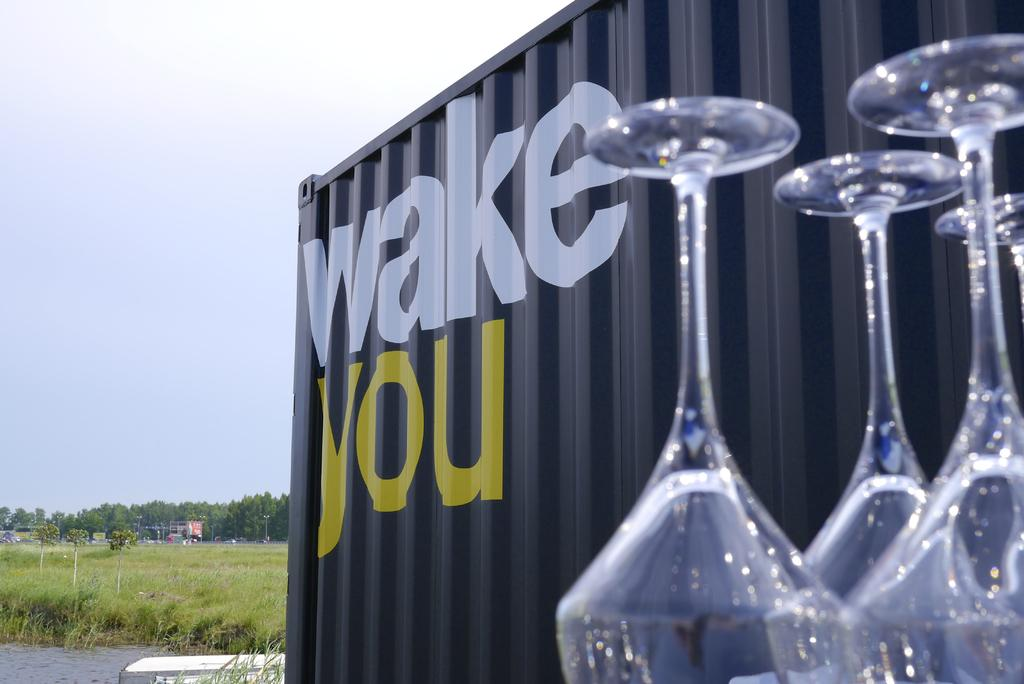What objects can be seen in the image? There are glasses and a metal object in the image. Where is the metal object located? The metal object is on the right side of the image. What can be seen in the background of the image? The sky is visible in the background of the image. What type of landscape is present in the image? There is a field in the image. What other natural elements can be seen in the image? Trees are present at the bottom of the image. How much debt is represented by the glasses in the image? The glasses in the image do not represent any debt; they are simply glasses. What type of scissors can be seen cutting the grass in the image? There are no scissors present in the image, and no grass is being cut. 